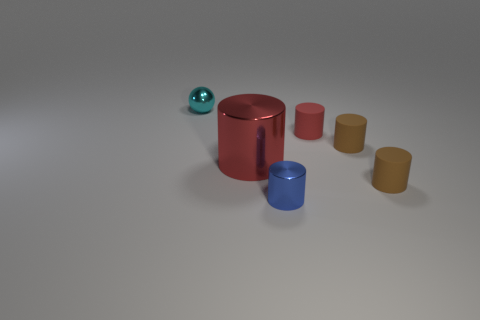What number of brown objects are the same size as the blue shiny object?
Provide a succinct answer. 2. There is a blue object; is it the same size as the red cylinder that is left of the tiny blue cylinder?
Give a very brief answer. No. How many things are either cyan shiny balls or small matte things?
Your answer should be compact. 4. How many tiny cylinders are the same color as the large metal thing?
Provide a short and direct response. 1. What shape is the cyan metallic object that is the same size as the blue cylinder?
Your response must be concise. Sphere. Is there another blue object that has the same shape as the large shiny object?
Keep it short and to the point. Yes. What number of large red objects have the same material as the tiny blue thing?
Offer a very short reply. 1. Is the material of the brown object in front of the big thing the same as the sphere?
Make the answer very short. No. Are there more small brown things that are to the left of the small blue metal cylinder than cyan metal objects right of the large cylinder?
Offer a very short reply. No. There is a red object that is the same size as the blue object; what material is it?
Ensure brevity in your answer.  Rubber. 